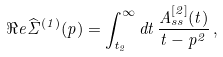<formula> <loc_0><loc_0><loc_500><loc_500>\Re e \widehat { \Sigma } ^ { ( 1 ) } ( p ) = \int _ { t _ { 2 } } ^ { \infty } d t \, \frac { A ^ { [ 2 ] } _ { s s } ( t ) } { t - p ^ { 2 } } \, ,</formula> 